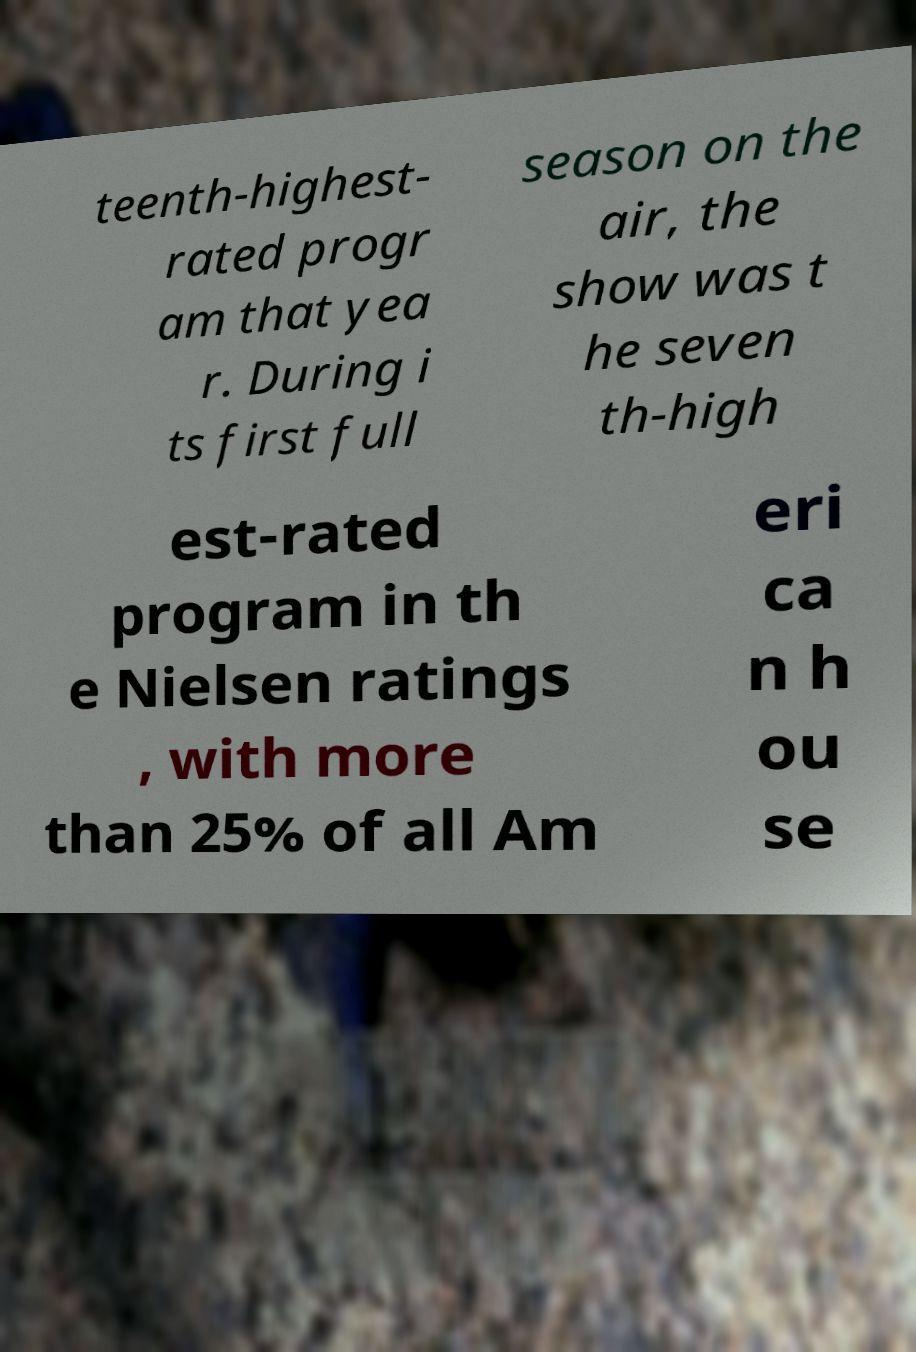Could you extract and type out the text from this image? teenth-highest- rated progr am that yea r. During i ts first full season on the air, the show was t he seven th-high est-rated program in th e Nielsen ratings , with more than 25% of all Am eri ca n h ou se 